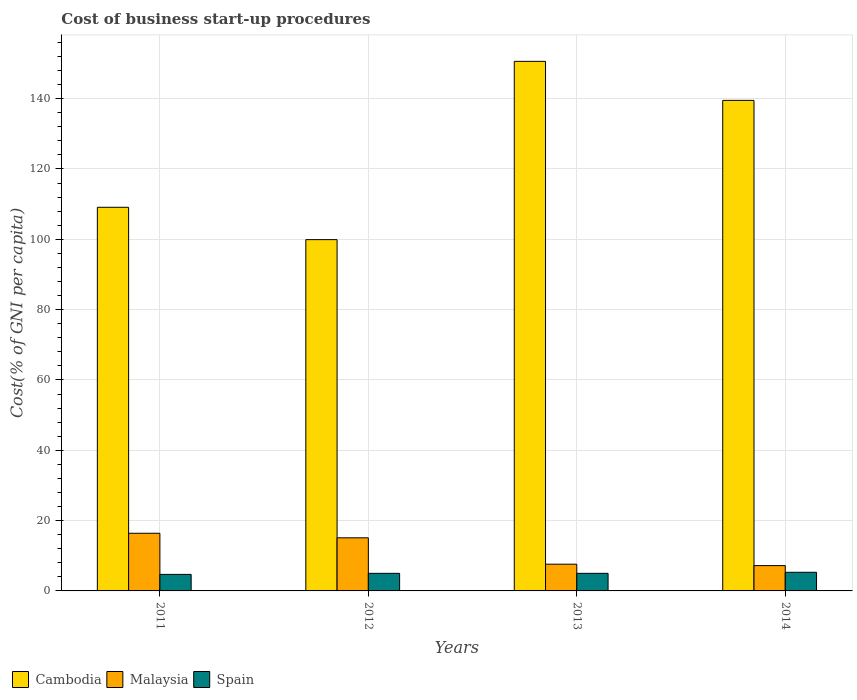How many different coloured bars are there?
Your answer should be very brief. 3. How many groups of bars are there?
Ensure brevity in your answer.  4. Are the number of bars per tick equal to the number of legend labels?
Your response must be concise. Yes. How many bars are there on the 2nd tick from the left?
Your answer should be compact. 3. How many bars are there on the 1st tick from the right?
Ensure brevity in your answer.  3. What is the label of the 3rd group of bars from the left?
Your response must be concise. 2013. Across all years, what is the maximum cost of business start-up procedures in Cambodia?
Your response must be concise. 150.6. Across all years, what is the minimum cost of business start-up procedures in Malaysia?
Keep it short and to the point. 7.2. In which year was the cost of business start-up procedures in Cambodia maximum?
Your answer should be compact. 2013. In which year was the cost of business start-up procedures in Malaysia minimum?
Your answer should be compact. 2014. What is the total cost of business start-up procedures in Spain in the graph?
Provide a succinct answer. 20. What is the difference between the cost of business start-up procedures in Cambodia in 2011 and that in 2012?
Your answer should be compact. 9.2. What is the difference between the cost of business start-up procedures in Malaysia in 2011 and the cost of business start-up procedures in Cambodia in 2012?
Your answer should be very brief. -83.5. What is the average cost of business start-up procedures in Cambodia per year?
Make the answer very short. 124.78. In the year 2013, what is the difference between the cost of business start-up procedures in Cambodia and cost of business start-up procedures in Malaysia?
Provide a short and direct response. 143. In how many years, is the cost of business start-up procedures in Spain greater than 88 %?
Your answer should be compact. 0. What is the ratio of the cost of business start-up procedures in Spain in 2011 to that in 2012?
Your answer should be very brief. 0.94. Is the cost of business start-up procedures in Malaysia in 2012 less than that in 2013?
Ensure brevity in your answer.  No. What is the difference between the highest and the second highest cost of business start-up procedures in Spain?
Provide a succinct answer. 0.3. What is the difference between the highest and the lowest cost of business start-up procedures in Cambodia?
Your response must be concise. 50.7. In how many years, is the cost of business start-up procedures in Malaysia greater than the average cost of business start-up procedures in Malaysia taken over all years?
Your answer should be very brief. 2. Is the sum of the cost of business start-up procedures in Cambodia in 2011 and 2012 greater than the maximum cost of business start-up procedures in Spain across all years?
Ensure brevity in your answer.  Yes. What does the 3rd bar from the left in 2011 represents?
Provide a succinct answer. Spain. What does the 1st bar from the right in 2011 represents?
Your answer should be very brief. Spain. How many bars are there?
Your response must be concise. 12. Are all the bars in the graph horizontal?
Provide a short and direct response. No. How many years are there in the graph?
Your response must be concise. 4. Does the graph contain any zero values?
Keep it short and to the point. No. Does the graph contain grids?
Keep it short and to the point. Yes. How many legend labels are there?
Ensure brevity in your answer.  3. What is the title of the graph?
Offer a very short reply. Cost of business start-up procedures. Does "Euro area" appear as one of the legend labels in the graph?
Your response must be concise. No. What is the label or title of the Y-axis?
Offer a terse response. Cost(% of GNI per capita). What is the Cost(% of GNI per capita) in Cambodia in 2011?
Ensure brevity in your answer.  109.1. What is the Cost(% of GNI per capita) in Spain in 2011?
Offer a very short reply. 4.7. What is the Cost(% of GNI per capita) of Cambodia in 2012?
Offer a very short reply. 99.9. What is the Cost(% of GNI per capita) of Cambodia in 2013?
Provide a succinct answer. 150.6. What is the Cost(% of GNI per capita) of Malaysia in 2013?
Your response must be concise. 7.6. What is the Cost(% of GNI per capita) of Cambodia in 2014?
Make the answer very short. 139.5. What is the Cost(% of GNI per capita) of Malaysia in 2014?
Give a very brief answer. 7.2. What is the Cost(% of GNI per capita) of Spain in 2014?
Your response must be concise. 5.3. Across all years, what is the maximum Cost(% of GNI per capita) of Cambodia?
Offer a very short reply. 150.6. Across all years, what is the maximum Cost(% of GNI per capita) in Spain?
Provide a succinct answer. 5.3. Across all years, what is the minimum Cost(% of GNI per capita) of Cambodia?
Make the answer very short. 99.9. Across all years, what is the minimum Cost(% of GNI per capita) in Malaysia?
Your response must be concise. 7.2. What is the total Cost(% of GNI per capita) of Cambodia in the graph?
Your response must be concise. 499.1. What is the total Cost(% of GNI per capita) in Malaysia in the graph?
Keep it short and to the point. 46.3. What is the total Cost(% of GNI per capita) in Spain in the graph?
Your response must be concise. 20. What is the difference between the Cost(% of GNI per capita) of Malaysia in 2011 and that in 2012?
Provide a succinct answer. 1.3. What is the difference between the Cost(% of GNI per capita) of Cambodia in 2011 and that in 2013?
Give a very brief answer. -41.5. What is the difference between the Cost(% of GNI per capita) in Malaysia in 2011 and that in 2013?
Keep it short and to the point. 8.8. What is the difference between the Cost(% of GNI per capita) in Cambodia in 2011 and that in 2014?
Your answer should be very brief. -30.4. What is the difference between the Cost(% of GNI per capita) of Cambodia in 2012 and that in 2013?
Provide a succinct answer. -50.7. What is the difference between the Cost(% of GNI per capita) of Malaysia in 2012 and that in 2013?
Give a very brief answer. 7.5. What is the difference between the Cost(% of GNI per capita) of Cambodia in 2012 and that in 2014?
Ensure brevity in your answer.  -39.6. What is the difference between the Cost(% of GNI per capita) in Cambodia in 2013 and that in 2014?
Your answer should be compact. 11.1. What is the difference between the Cost(% of GNI per capita) in Malaysia in 2013 and that in 2014?
Ensure brevity in your answer.  0.4. What is the difference between the Cost(% of GNI per capita) in Cambodia in 2011 and the Cost(% of GNI per capita) in Malaysia in 2012?
Give a very brief answer. 94. What is the difference between the Cost(% of GNI per capita) in Cambodia in 2011 and the Cost(% of GNI per capita) in Spain in 2012?
Your answer should be very brief. 104.1. What is the difference between the Cost(% of GNI per capita) of Cambodia in 2011 and the Cost(% of GNI per capita) of Malaysia in 2013?
Give a very brief answer. 101.5. What is the difference between the Cost(% of GNI per capita) of Cambodia in 2011 and the Cost(% of GNI per capita) of Spain in 2013?
Offer a terse response. 104.1. What is the difference between the Cost(% of GNI per capita) in Malaysia in 2011 and the Cost(% of GNI per capita) in Spain in 2013?
Offer a very short reply. 11.4. What is the difference between the Cost(% of GNI per capita) of Cambodia in 2011 and the Cost(% of GNI per capita) of Malaysia in 2014?
Offer a terse response. 101.9. What is the difference between the Cost(% of GNI per capita) of Cambodia in 2011 and the Cost(% of GNI per capita) of Spain in 2014?
Your response must be concise. 103.8. What is the difference between the Cost(% of GNI per capita) in Malaysia in 2011 and the Cost(% of GNI per capita) in Spain in 2014?
Offer a terse response. 11.1. What is the difference between the Cost(% of GNI per capita) in Cambodia in 2012 and the Cost(% of GNI per capita) in Malaysia in 2013?
Your response must be concise. 92.3. What is the difference between the Cost(% of GNI per capita) of Cambodia in 2012 and the Cost(% of GNI per capita) of Spain in 2013?
Provide a short and direct response. 94.9. What is the difference between the Cost(% of GNI per capita) in Malaysia in 2012 and the Cost(% of GNI per capita) in Spain in 2013?
Provide a short and direct response. 10.1. What is the difference between the Cost(% of GNI per capita) in Cambodia in 2012 and the Cost(% of GNI per capita) in Malaysia in 2014?
Offer a very short reply. 92.7. What is the difference between the Cost(% of GNI per capita) in Cambodia in 2012 and the Cost(% of GNI per capita) in Spain in 2014?
Keep it short and to the point. 94.6. What is the difference between the Cost(% of GNI per capita) in Malaysia in 2012 and the Cost(% of GNI per capita) in Spain in 2014?
Make the answer very short. 9.8. What is the difference between the Cost(% of GNI per capita) in Cambodia in 2013 and the Cost(% of GNI per capita) in Malaysia in 2014?
Keep it short and to the point. 143.4. What is the difference between the Cost(% of GNI per capita) in Cambodia in 2013 and the Cost(% of GNI per capita) in Spain in 2014?
Your response must be concise. 145.3. What is the average Cost(% of GNI per capita) in Cambodia per year?
Provide a short and direct response. 124.78. What is the average Cost(% of GNI per capita) of Malaysia per year?
Your answer should be very brief. 11.57. What is the average Cost(% of GNI per capita) in Spain per year?
Ensure brevity in your answer.  5. In the year 2011, what is the difference between the Cost(% of GNI per capita) of Cambodia and Cost(% of GNI per capita) of Malaysia?
Give a very brief answer. 92.7. In the year 2011, what is the difference between the Cost(% of GNI per capita) of Cambodia and Cost(% of GNI per capita) of Spain?
Your answer should be very brief. 104.4. In the year 2011, what is the difference between the Cost(% of GNI per capita) of Malaysia and Cost(% of GNI per capita) of Spain?
Provide a short and direct response. 11.7. In the year 2012, what is the difference between the Cost(% of GNI per capita) in Cambodia and Cost(% of GNI per capita) in Malaysia?
Give a very brief answer. 84.8. In the year 2012, what is the difference between the Cost(% of GNI per capita) in Cambodia and Cost(% of GNI per capita) in Spain?
Keep it short and to the point. 94.9. In the year 2013, what is the difference between the Cost(% of GNI per capita) of Cambodia and Cost(% of GNI per capita) of Malaysia?
Offer a terse response. 143. In the year 2013, what is the difference between the Cost(% of GNI per capita) in Cambodia and Cost(% of GNI per capita) in Spain?
Ensure brevity in your answer.  145.6. In the year 2014, what is the difference between the Cost(% of GNI per capita) of Cambodia and Cost(% of GNI per capita) of Malaysia?
Keep it short and to the point. 132.3. In the year 2014, what is the difference between the Cost(% of GNI per capita) of Cambodia and Cost(% of GNI per capita) of Spain?
Provide a short and direct response. 134.2. In the year 2014, what is the difference between the Cost(% of GNI per capita) in Malaysia and Cost(% of GNI per capita) in Spain?
Offer a terse response. 1.9. What is the ratio of the Cost(% of GNI per capita) in Cambodia in 2011 to that in 2012?
Make the answer very short. 1.09. What is the ratio of the Cost(% of GNI per capita) in Malaysia in 2011 to that in 2012?
Your response must be concise. 1.09. What is the ratio of the Cost(% of GNI per capita) of Cambodia in 2011 to that in 2013?
Make the answer very short. 0.72. What is the ratio of the Cost(% of GNI per capita) of Malaysia in 2011 to that in 2013?
Keep it short and to the point. 2.16. What is the ratio of the Cost(% of GNI per capita) of Spain in 2011 to that in 2013?
Give a very brief answer. 0.94. What is the ratio of the Cost(% of GNI per capita) in Cambodia in 2011 to that in 2014?
Ensure brevity in your answer.  0.78. What is the ratio of the Cost(% of GNI per capita) of Malaysia in 2011 to that in 2014?
Your answer should be very brief. 2.28. What is the ratio of the Cost(% of GNI per capita) in Spain in 2011 to that in 2014?
Keep it short and to the point. 0.89. What is the ratio of the Cost(% of GNI per capita) in Cambodia in 2012 to that in 2013?
Give a very brief answer. 0.66. What is the ratio of the Cost(% of GNI per capita) of Malaysia in 2012 to that in 2013?
Keep it short and to the point. 1.99. What is the ratio of the Cost(% of GNI per capita) of Cambodia in 2012 to that in 2014?
Give a very brief answer. 0.72. What is the ratio of the Cost(% of GNI per capita) in Malaysia in 2012 to that in 2014?
Your response must be concise. 2.1. What is the ratio of the Cost(% of GNI per capita) of Spain in 2012 to that in 2014?
Keep it short and to the point. 0.94. What is the ratio of the Cost(% of GNI per capita) in Cambodia in 2013 to that in 2014?
Offer a terse response. 1.08. What is the ratio of the Cost(% of GNI per capita) of Malaysia in 2013 to that in 2014?
Provide a short and direct response. 1.06. What is the ratio of the Cost(% of GNI per capita) in Spain in 2013 to that in 2014?
Your answer should be compact. 0.94. What is the difference between the highest and the second highest Cost(% of GNI per capita) of Malaysia?
Provide a succinct answer. 1.3. What is the difference between the highest and the second highest Cost(% of GNI per capita) of Spain?
Make the answer very short. 0.3. What is the difference between the highest and the lowest Cost(% of GNI per capita) of Cambodia?
Offer a terse response. 50.7. What is the difference between the highest and the lowest Cost(% of GNI per capita) in Spain?
Keep it short and to the point. 0.6. 